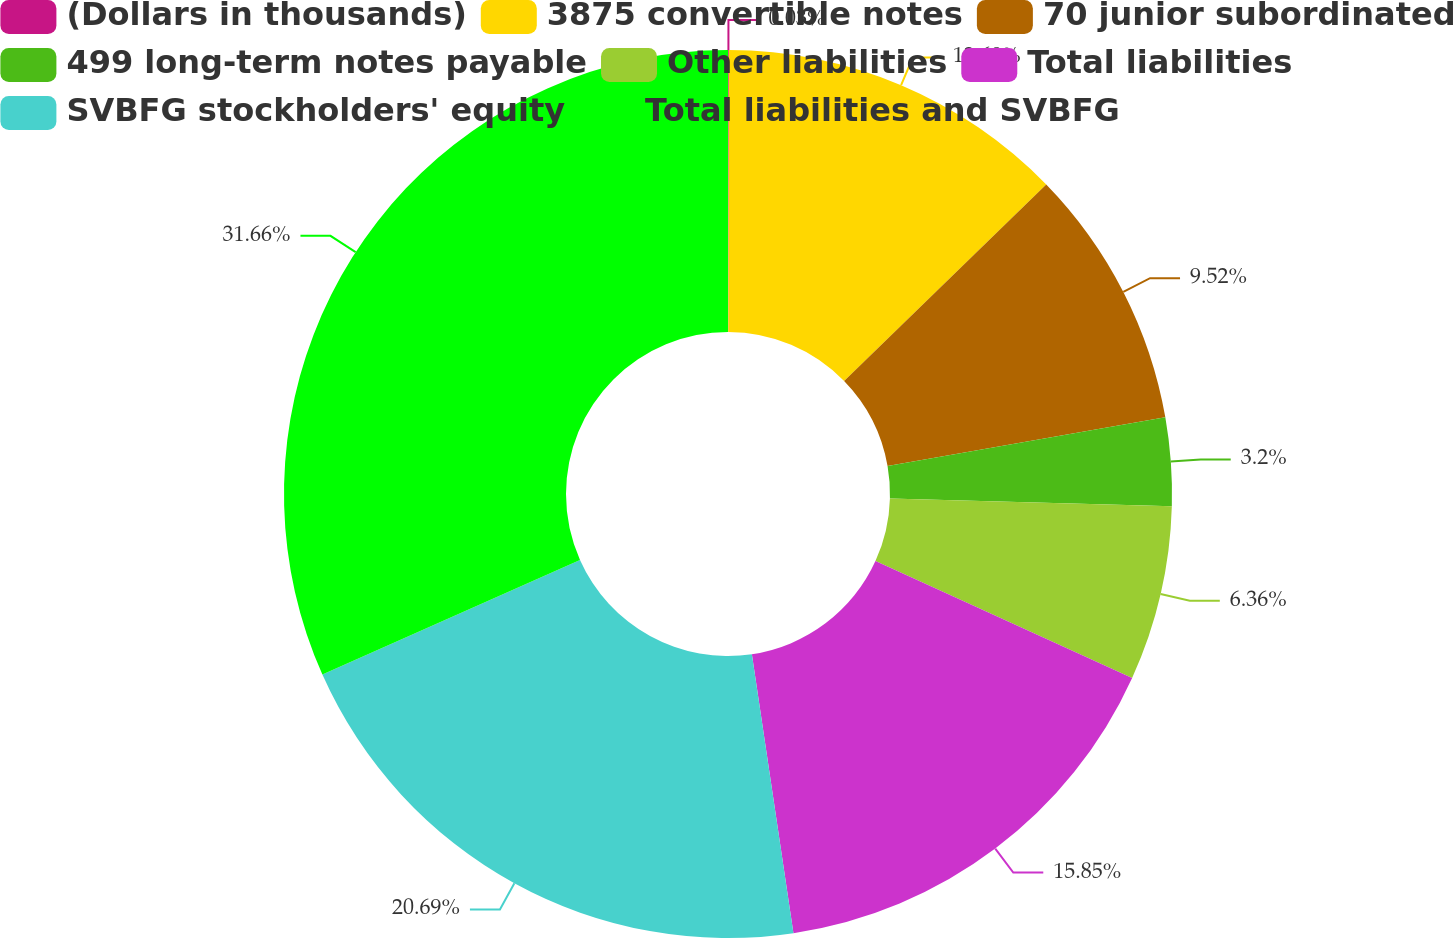<chart> <loc_0><loc_0><loc_500><loc_500><pie_chart><fcel>(Dollars in thousands)<fcel>3875 convertible notes<fcel>70 junior subordinated<fcel>499 long-term notes payable<fcel>Other liabilities<fcel>Total liabilities<fcel>SVBFG stockholders' equity<fcel>Total liabilities and SVBFG<nl><fcel>0.03%<fcel>12.69%<fcel>9.52%<fcel>3.2%<fcel>6.36%<fcel>15.85%<fcel>20.69%<fcel>31.67%<nl></chart> 